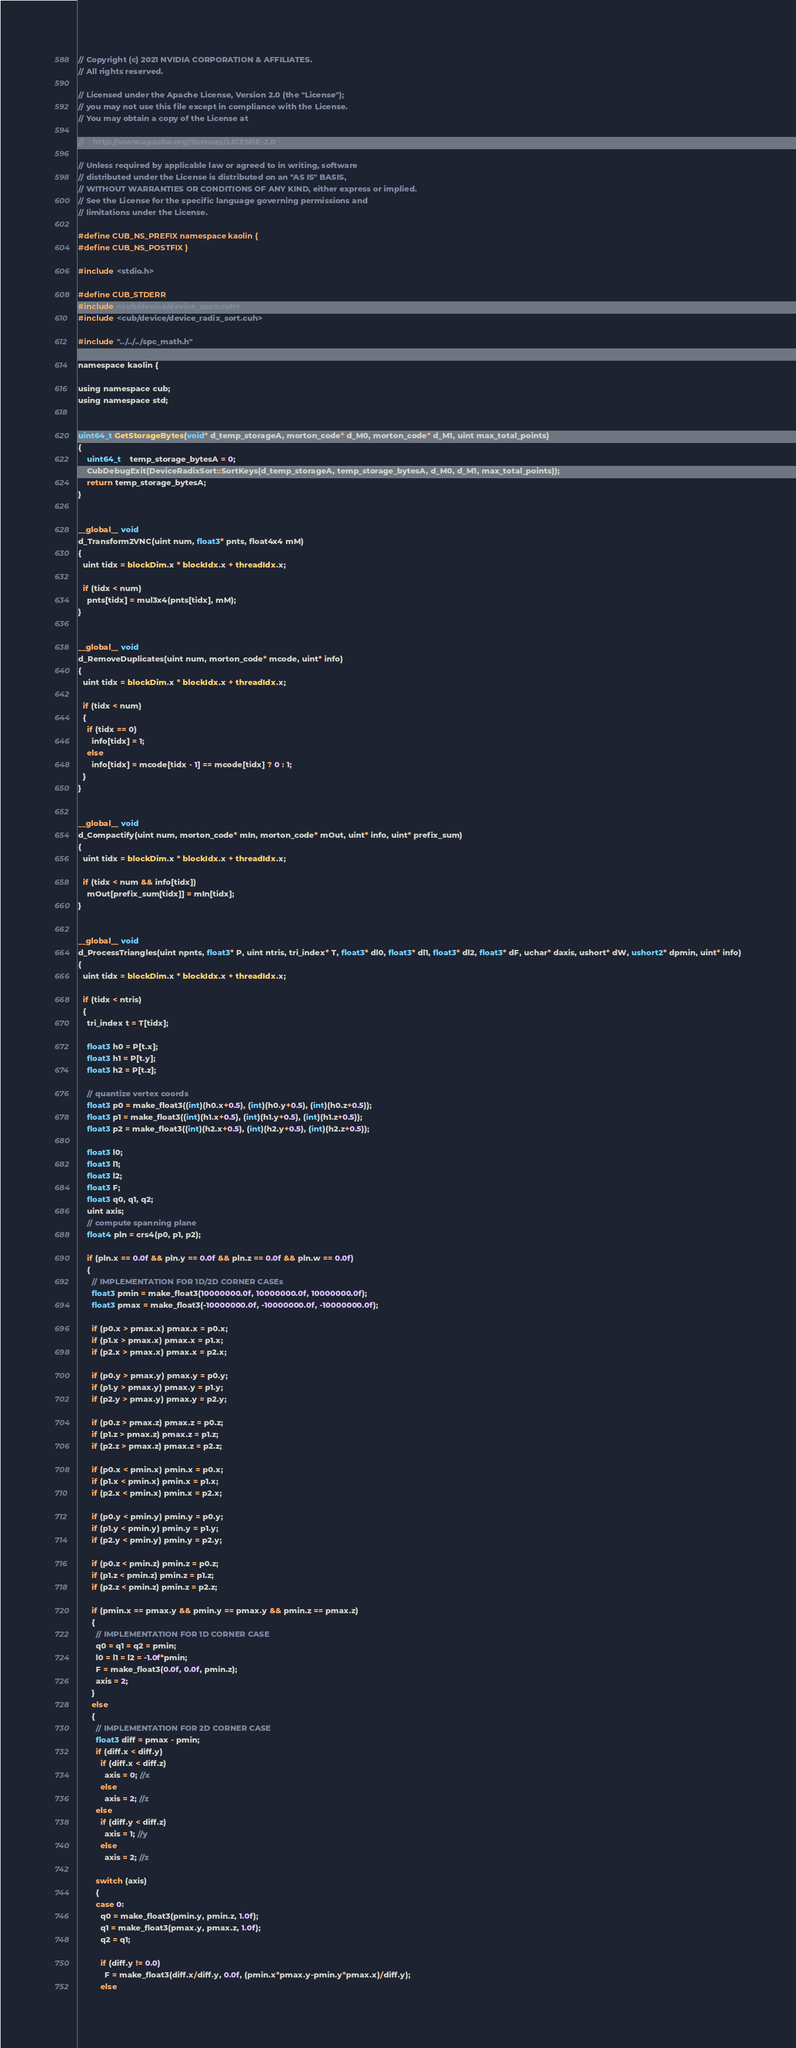Convert code to text. <code><loc_0><loc_0><loc_500><loc_500><_Cuda_>// Copyright (c) 2021 NVIDIA CORPORATION & AFFILIATES.
// All rights reserved.

// Licensed under the Apache License, Version 2.0 (the "License");
// you may not use this file except in compliance with the License.
// You may obtain a copy of the License at

//    http://www.apache.org/licenses/LICENSE-2.0

// Unless required by applicable law or agreed to in writing, software
// distributed under the License is distributed on an "AS IS" BASIS,
// WITHOUT WARRANTIES OR CONDITIONS OF ANY KIND, either express or implied.
// See the License for the specific language governing permissions and
// limitations under the License.

#define CUB_NS_PREFIX namespace kaolin {
#define CUB_NS_POSTFIX }

#include <stdio.h>

#define CUB_STDERR
#include <cub/device/device_scan.cuh>
#include <cub/device/device_radix_sort.cuh>

#include "../../../spc_math.h"

namespace kaolin {

using namespace cub;
using namespace std;


uint64_t GetStorageBytes(void* d_temp_storageA, morton_code* d_M0, morton_code* d_M1, uint max_total_points)
{
    uint64_t    temp_storage_bytesA = 0;
    CubDebugExit(DeviceRadixSort::SortKeys(d_temp_storageA, temp_storage_bytesA, d_M0, d_M1, max_total_points));
    return temp_storage_bytesA;
}


__global__ void
d_Transform2VNC(uint num, float3* pnts, float4x4 mM)
{
  uint tidx = blockDim.x * blockIdx.x + threadIdx.x;

  if (tidx < num)
    pnts[tidx] = mul3x4(pnts[tidx], mM);
}


__global__ void
d_RemoveDuplicates(uint num, morton_code* mcode, uint* info)
{
  uint tidx = blockDim.x * blockIdx.x + threadIdx.x;

  if (tidx < num)
  {
    if (tidx == 0)
      info[tidx] = 1;
    else
      info[tidx] = mcode[tidx - 1] == mcode[tidx] ? 0 : 1;
  }
}


__global__ void
d_Compactify(uint num, morton_code* mIn, morton_code* mOut, uint* info, uint* prefix_sum)
{
  uint tidx = blockDim.x * blockIdx.x + threadIdx.x;

  if (tidx < num && info[tidx])
    mOut[prefix_sum[tidx]] = mIn[tidx];
}


__global__ void
d_ProcessTriangles(uint npnts, float3* P, uint ntris, tri_index* T, float3* dl0, float3* dl1, float3* dl2, float3* dF, uchar* daxis, ushort* dW, ushort2* dpmin, uint* info)
{
  uint tidx = blockDim.x * blockIdx.x + threadIdx.x;

  if (tidx < ntris)
  {
    tri_index t = T[tidx];

    float3 h0 = P[t.x];
    float3 h1 = P[t.y];
    float3 h2 = P[t.z];

    // quantize vertex coords
    float3 p0 = make_float3((int)(h0.x+0.5), (int)(h0.y+0.5), (int)(h0.z+0.5));
    float3 p1 = make_float3((int)(h1.x+0.5), (int)(h1.y+0.5), (int)(h1.z+0.5));
    float3 p2 = make_float3((int)(h2.x+0.5), (int)(h2.y+0.5), (int)(h2.z+0.5));

    float3 l0;
    float3 l1;
    float3 l2;
    float3 F;
    float3 q0, q1, q2;
    uint axis;
    // compute spanning plane
    float4 pln = crs4(p0, p1, p2);

    if (pln.x == 0.0f && pln.y == 0.0f && pln.z == 0.0f && pln.w == 0.0f)
    {
      // IMPLEMENTATION FOR 1D/2D CORNER CASEs
      float3 pmin = make_float3(10000000.0f, 10000000.0f, 10000000.0f);
      float3 pmax = make_float3(-10000000.0f, -10000000.0f, -10000000.0f);

      if (p0.x > pmax.x) pmax.x = p0.x;
      if (p1.x > pmax.x) pmax.x = p1.x;
      if (p2.x > pmax.x) pmax.x = p2.x;

      if (p0.y > pmax.y) pmax.y = p0.y;
      if (p1.y > pmax.y) pmax.y = p1.y;
      if (p2.y > pmax.y) pmax.y = p2.y;

      if (p0.z > pmax.z) pmax.z = p0.z;
      if (p1.z > pmax.z) pmax.z = p1.z;
      if (p2.z > pmax.z) pmax.z = p2.z;

      if (p0.x < pmin.x) pmin.x = p0.x;
      if (p1.x < pmin.x) pmin.x = p1.x;
      if (p2.x < pmin.x) pmin.x = p2.x;

      if (p0.y < pmin.y) pmin.y = p0.y;
      if (p1.y < pmin.y) pmin.y = p1.y;
      if (p2.y < pmin.y) pmin.y = p2.y;

      if (p0.z < pmin.z) pmin.z = p0.z;
      if (p1.z < pmin.z) pmin.z = p1.z;
      if (p2.z < pmin.z) pmin.z = p2.z;

      if (pmin.x == pmax.y && pmin.y == pmax.y && pmin.z == pmax.z)
      {
        // IMPLEMENTATION FOR 1D CORNER CASE
        q0 = q1 = q2 = pmin;
        l0 = l1 = l2 = -1.0f*pmin;
        F = make_float3(0.0f, 0.0f, pmin.z);
        axis = 2;
      }
      else
      {
        // IMPLEMENTATION FOR 2D CORNER CASE
        float3 diff = pmax - pmin;
        if (diff.x < diff.y)
          if (diff.x < diff.z)
            axis = 0; //x
          else
            axis = 2; //z
        else
          if (diff.y < diff.z)
            axis = 1; //y
          else
            axis = 2; //z

        switch (axis)
        {
        case 0:
          q0 = make_float3(pmin.y, pmin.z, 1.0f);
          q1 = make_float3(pmax.y, pmax.z, 1.0f);
          q2 = q1;

          if (diff.y != 0.0)
            F = make_float3(diff.x/diff.y, 0.0f, (pmin.x*pmax.y-pmin.y*pmax.x)/diff.y);
          else</code> 